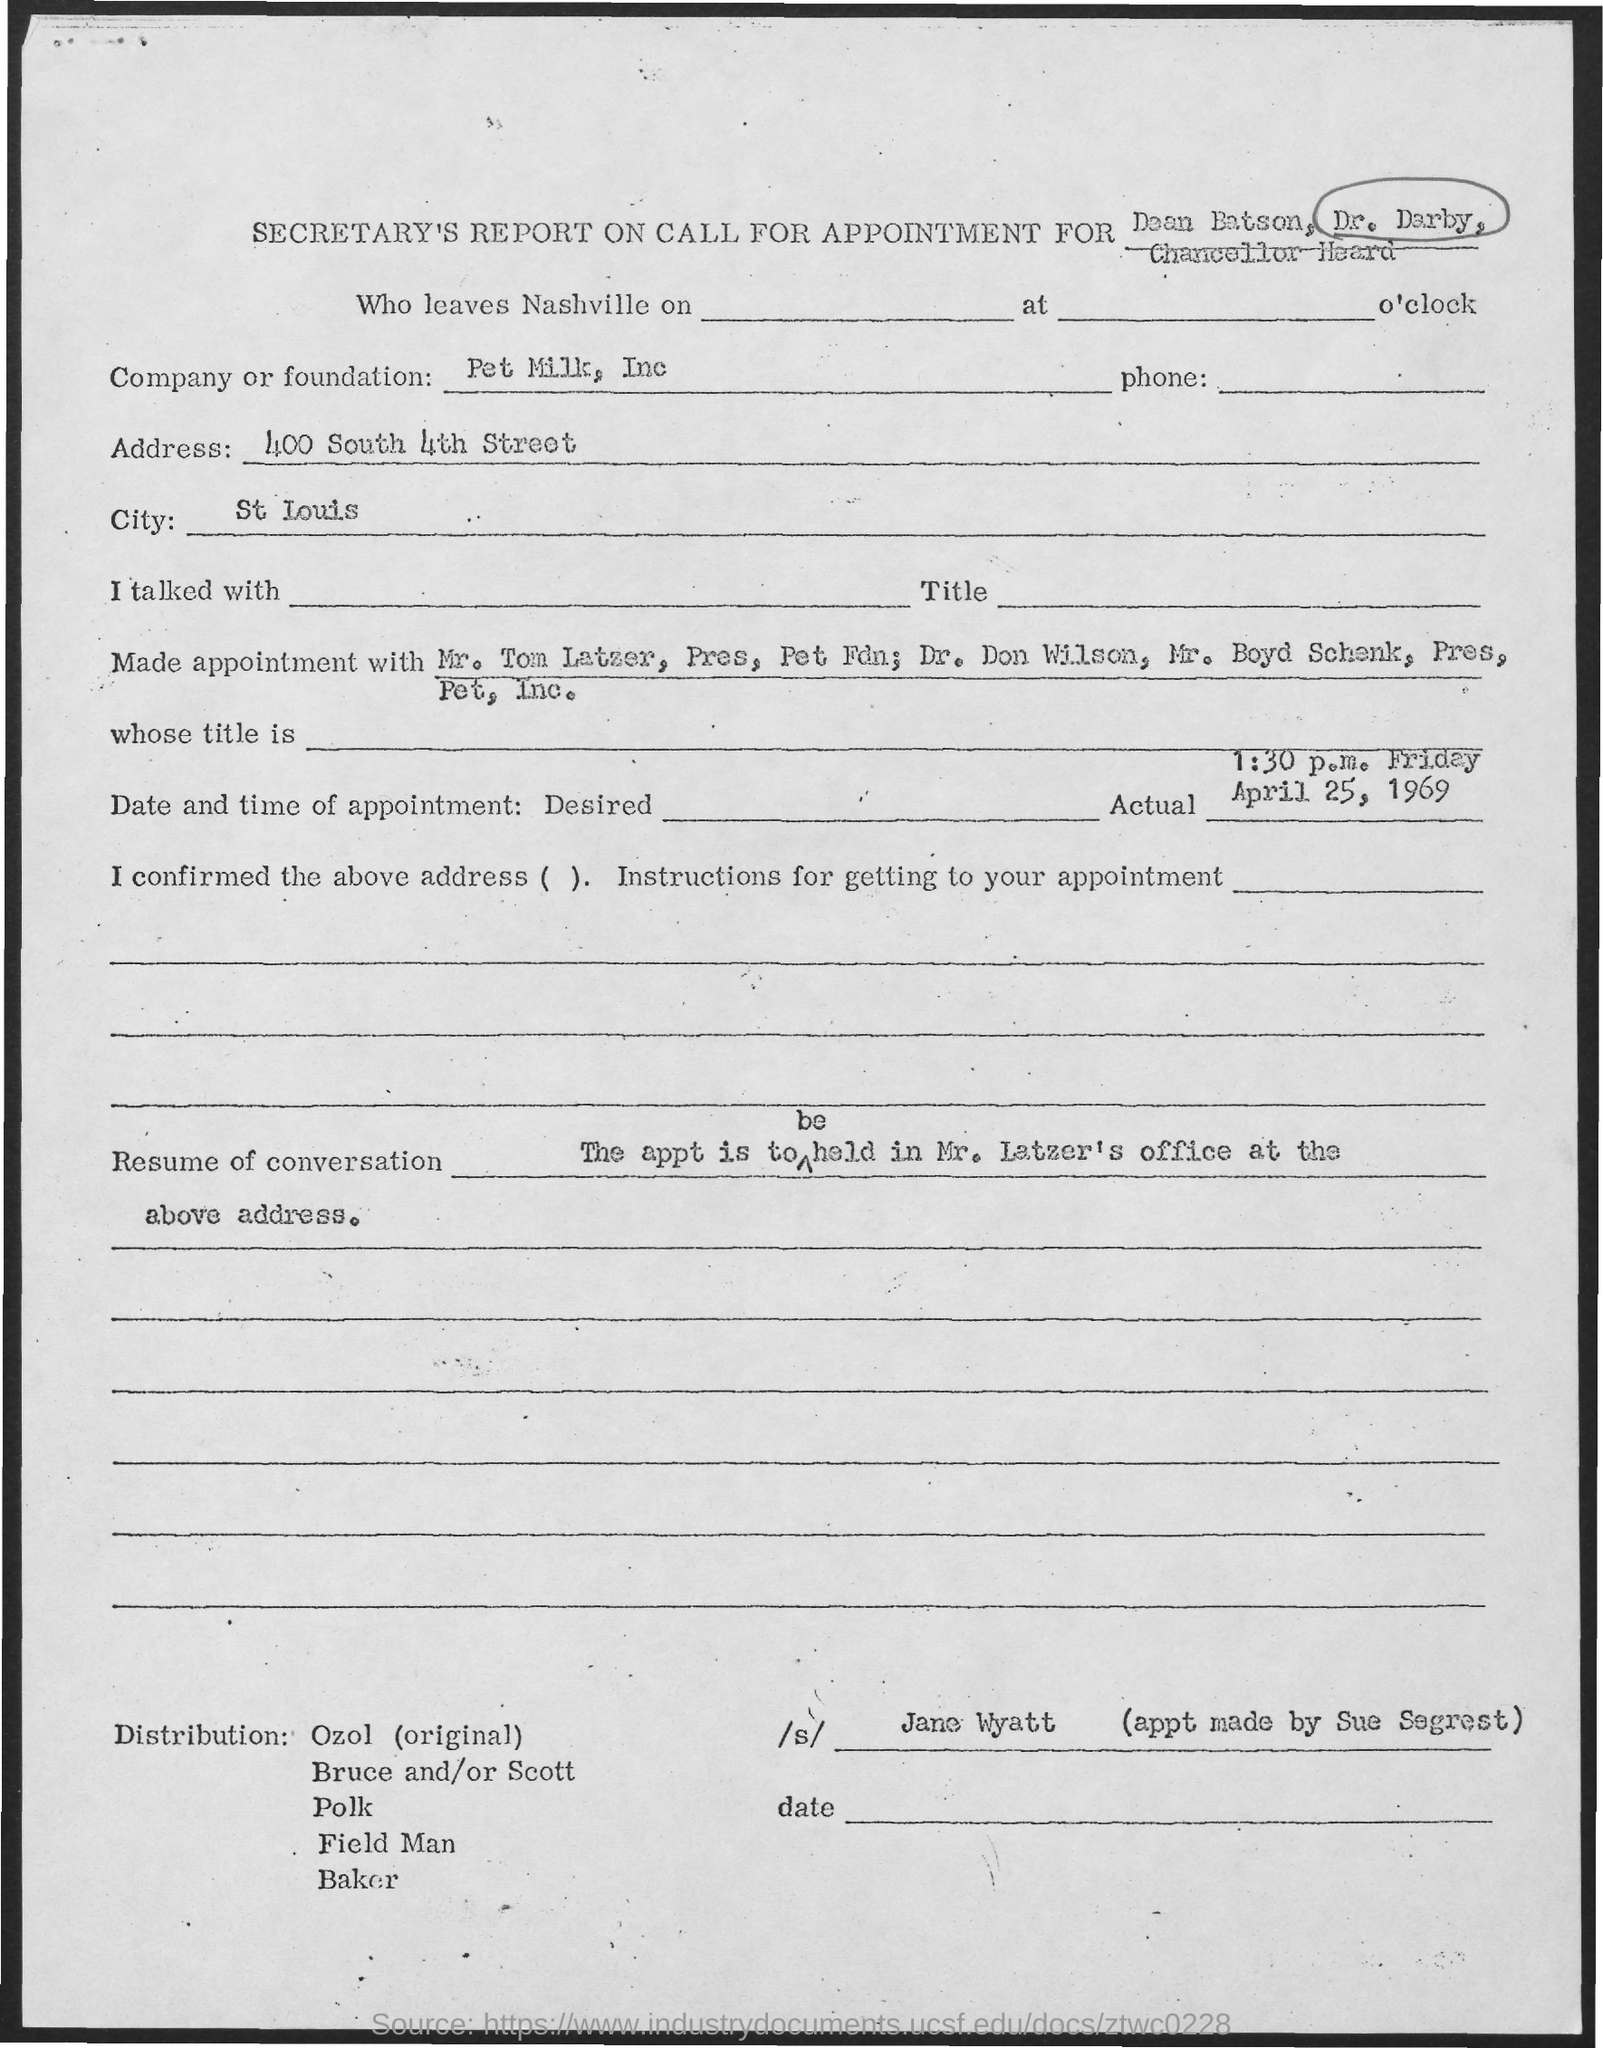List a handful of essential elements in this visual. The City, specifically in St. Louis, is... Pet Milk, Inc. is a company or foundation. The appointment was made by Sue Segrest. The address is 400 South 4th street. The actual date and time of the appointment is 1:30 p.m. on Friday, April 25, 1969. 